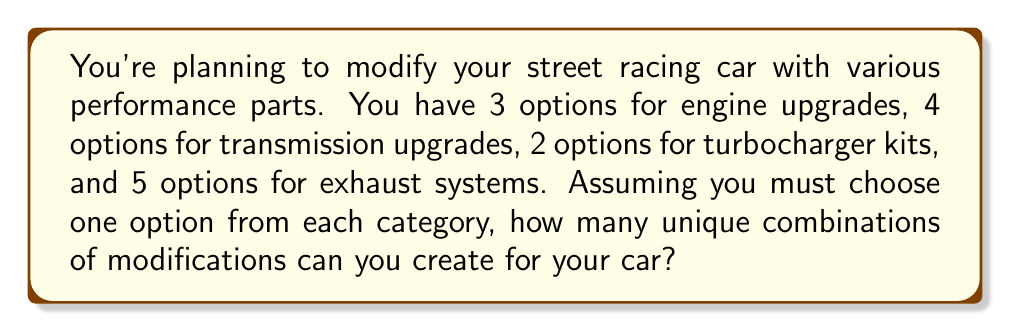Teach me how to tackle this problem. To solve this problem, we'll use the multiplication principle from group theory. This principle states that if we have a sequence of independent choices, the total number of possible outcomes is the product of the number of options for each choice.

Let's break down the problem:

1. Engine upgrades: 3 options
2. Transmission upgrades: 4 options
3. Turbocharger kits: 2 options
4. Exhaust systems: 5 options

Since we must choose one option from each category, and the choices are independent of each other, we can apply the multiplication principle:

$$ \text{Total combinations} = 3 \times 4 \times 2 \times 5 $$

Now, let's calculate:

$$ \begin{align*}
\text{Total combinations} &= 3 \times 4 \times 2 \times 5 \\
&= 12 \times 2 \times 5 \\
&= 24 \times 5 \\
&= 120
\end{align*} $$

Therefore, there are 120 unique combinations of modifications you can create for your street racing car.
Answer: 120 unique combinations 